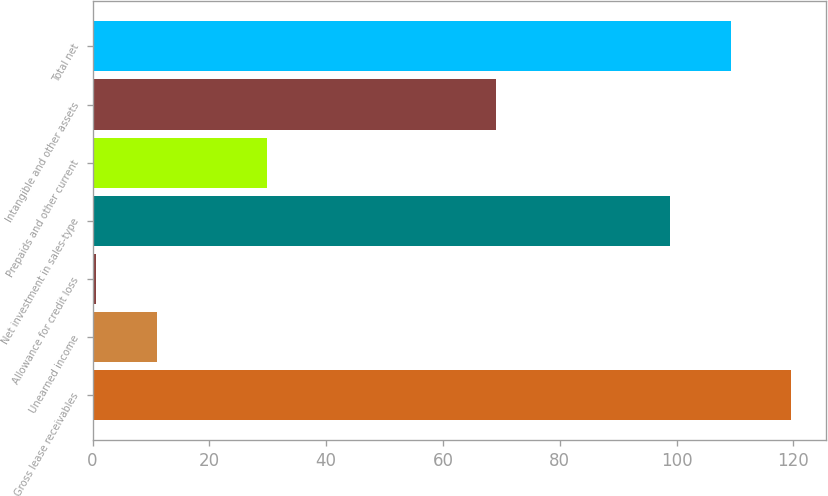<chart> <loc_0><loc_0><loc_500><loc_500><bar_chart><fcel>Gross lease receivables<fcel>Unearned income<fcel>Allowance for credit loss<fcel>Net investment in sales-type<fcel>Prepaids and other current<fcel>Intangible and other assets<fcel>Total net<nl><fcel>119.64<fcel>10.97<fcel>0.6<fcel>98.9<fcel>29.8<fcel>69.1<fcel>109.27<nl></chart> 